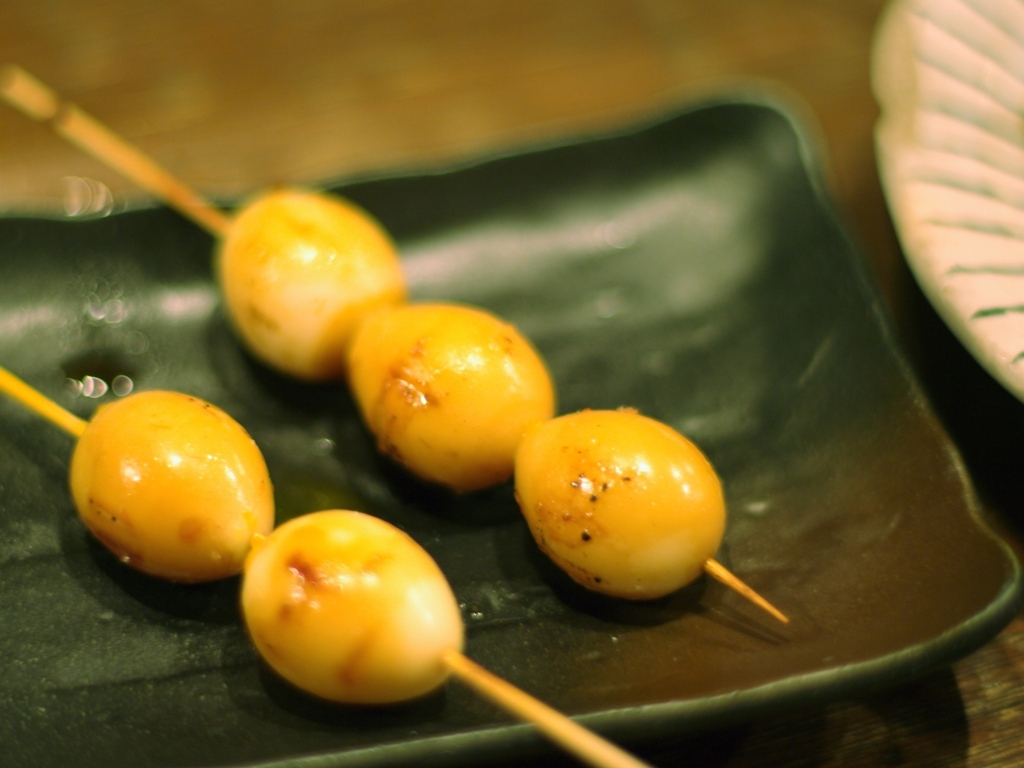Could you suggest a suitable occasion or setting where this kind of food might commonly be enjoyed? This type of skewered food is ideal for festive occasions such as street fairs, festivals, and outdoor markets. It's a portable snack that's easy to eat while walking around. They're also popular at izakayas, which are Japanese gastropubs, as a shared appetizer enjoyed with drinks. 